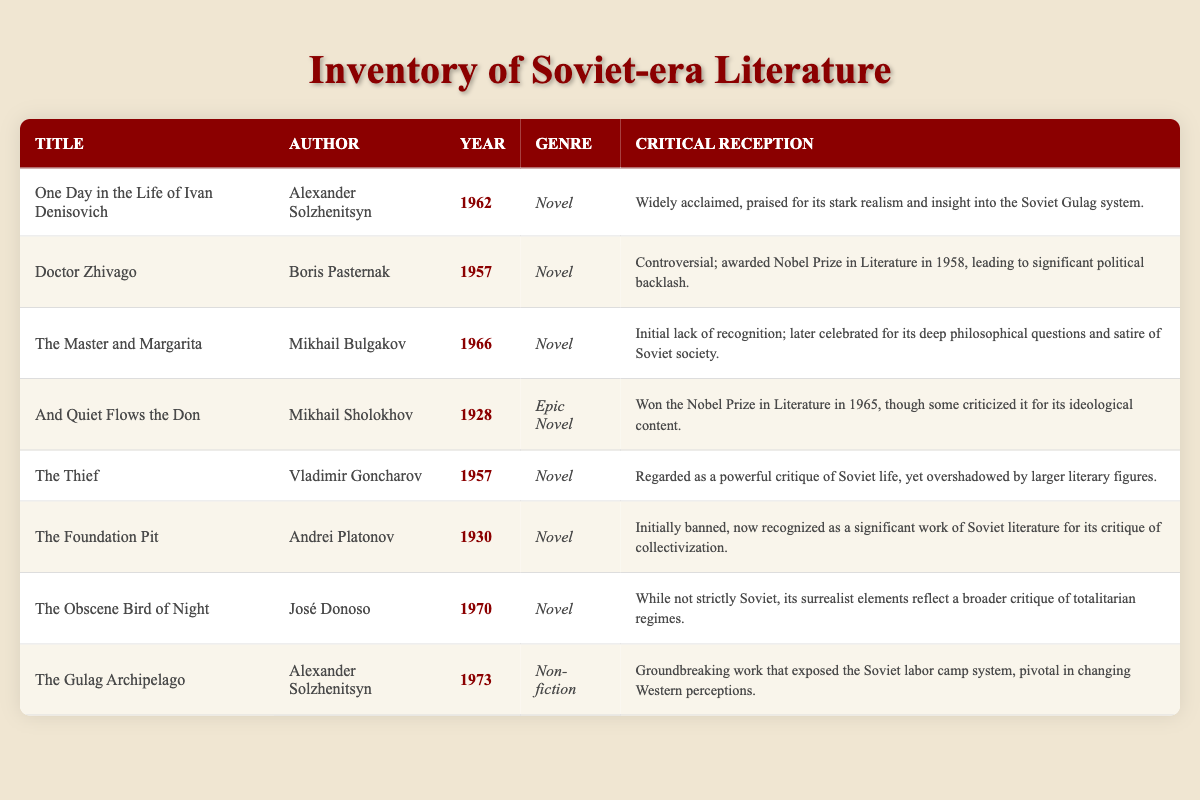What is the publication year of "Doctor Zhivago"? The table lists "Doctor Zhivago" with its publication year under the "Year" column, which shows 1957 next to this title.
Answer: 1957 Which two authors won the Nobel Prize in Literature? By reviewing the "Author" and "Critical Reception" columns, "Boris Pasternak" received the Nobel Prize in 1958 for "Doctor Zhivago," and "Mikhail Sholokhov" won it in 1965 for "And Quiet Flows the Don."
Answer: Boris Pasternak and Mikhail Sholokhov How many novels were published before 1960? Analyzing the "Publication Year" column, the novels published before 1960 are "And Quiet Flows the Don" (1928), "Doctor Zhivago" (1957), "The Thief" (1957), and "The Foundation Pit" (1930). This totals four novels.
Answer: 4 Is "The Master and Margarita" critically acclaimed? The "Critical Reception" column indicates that although "The Master and Margarita" initially lacked recognition, it was celebrated later for its philosophical depth and satire of Soviet society, implying a positive critical reception.
Answer: Yes What genre does "The Gulag Archipelago" belong to, and what is its critical reception? By checking the "Genre" and "Critical Reception" columns, "The Gulag Archipelago" is classified as "Non-fiction," and its critical reception is described as a groundbreaking work that changed perceptions about the Soviet labor camp system.
Answer: Non-fiction; Groundbreaking work Which novel received significant political backlash upon its award of the Nobel Prize? Looking at the "Critical Reception" column for "Doctor Zhivago," it states that the Nobel Prize award in 1958 led to significant political backlash, indicating a strong negative reaction to the recognition of this work.
Answer: Doctor Zhivago What is the average publication year of the novels in the table? The publication years of the novels are 1962, 1957, 1966, 1928, 1957, 1930, and 1970. Calculating the average involves summing these years (1962 + 1957 + 1966 + 1928 + 1957 + 1930 + 1970 = 13770) and dividing by the number of novels (7), which results in approximately 1967.14, and rounding gives 1967.
Answer: 1967 